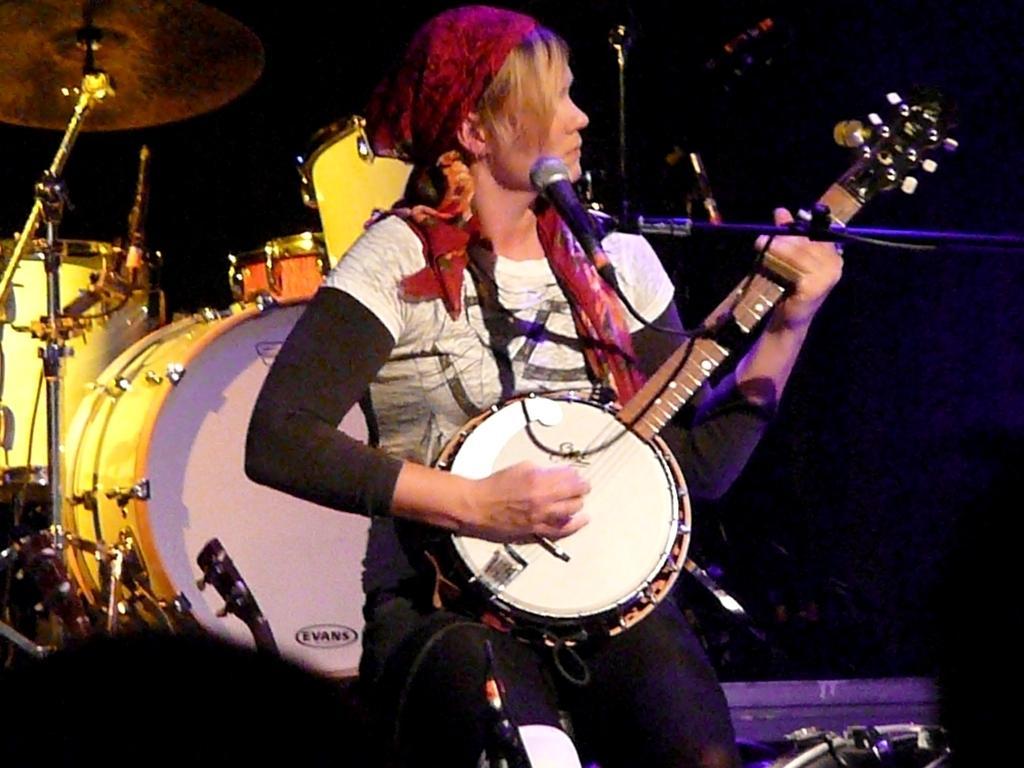Please provide a concise description of this image. In this picture I can see a woman in front who is standing and I see that she is holding a musical instrument in her hands and I see a mic in front of her. In the background I see few more musical instruments and it is a bit dark. 